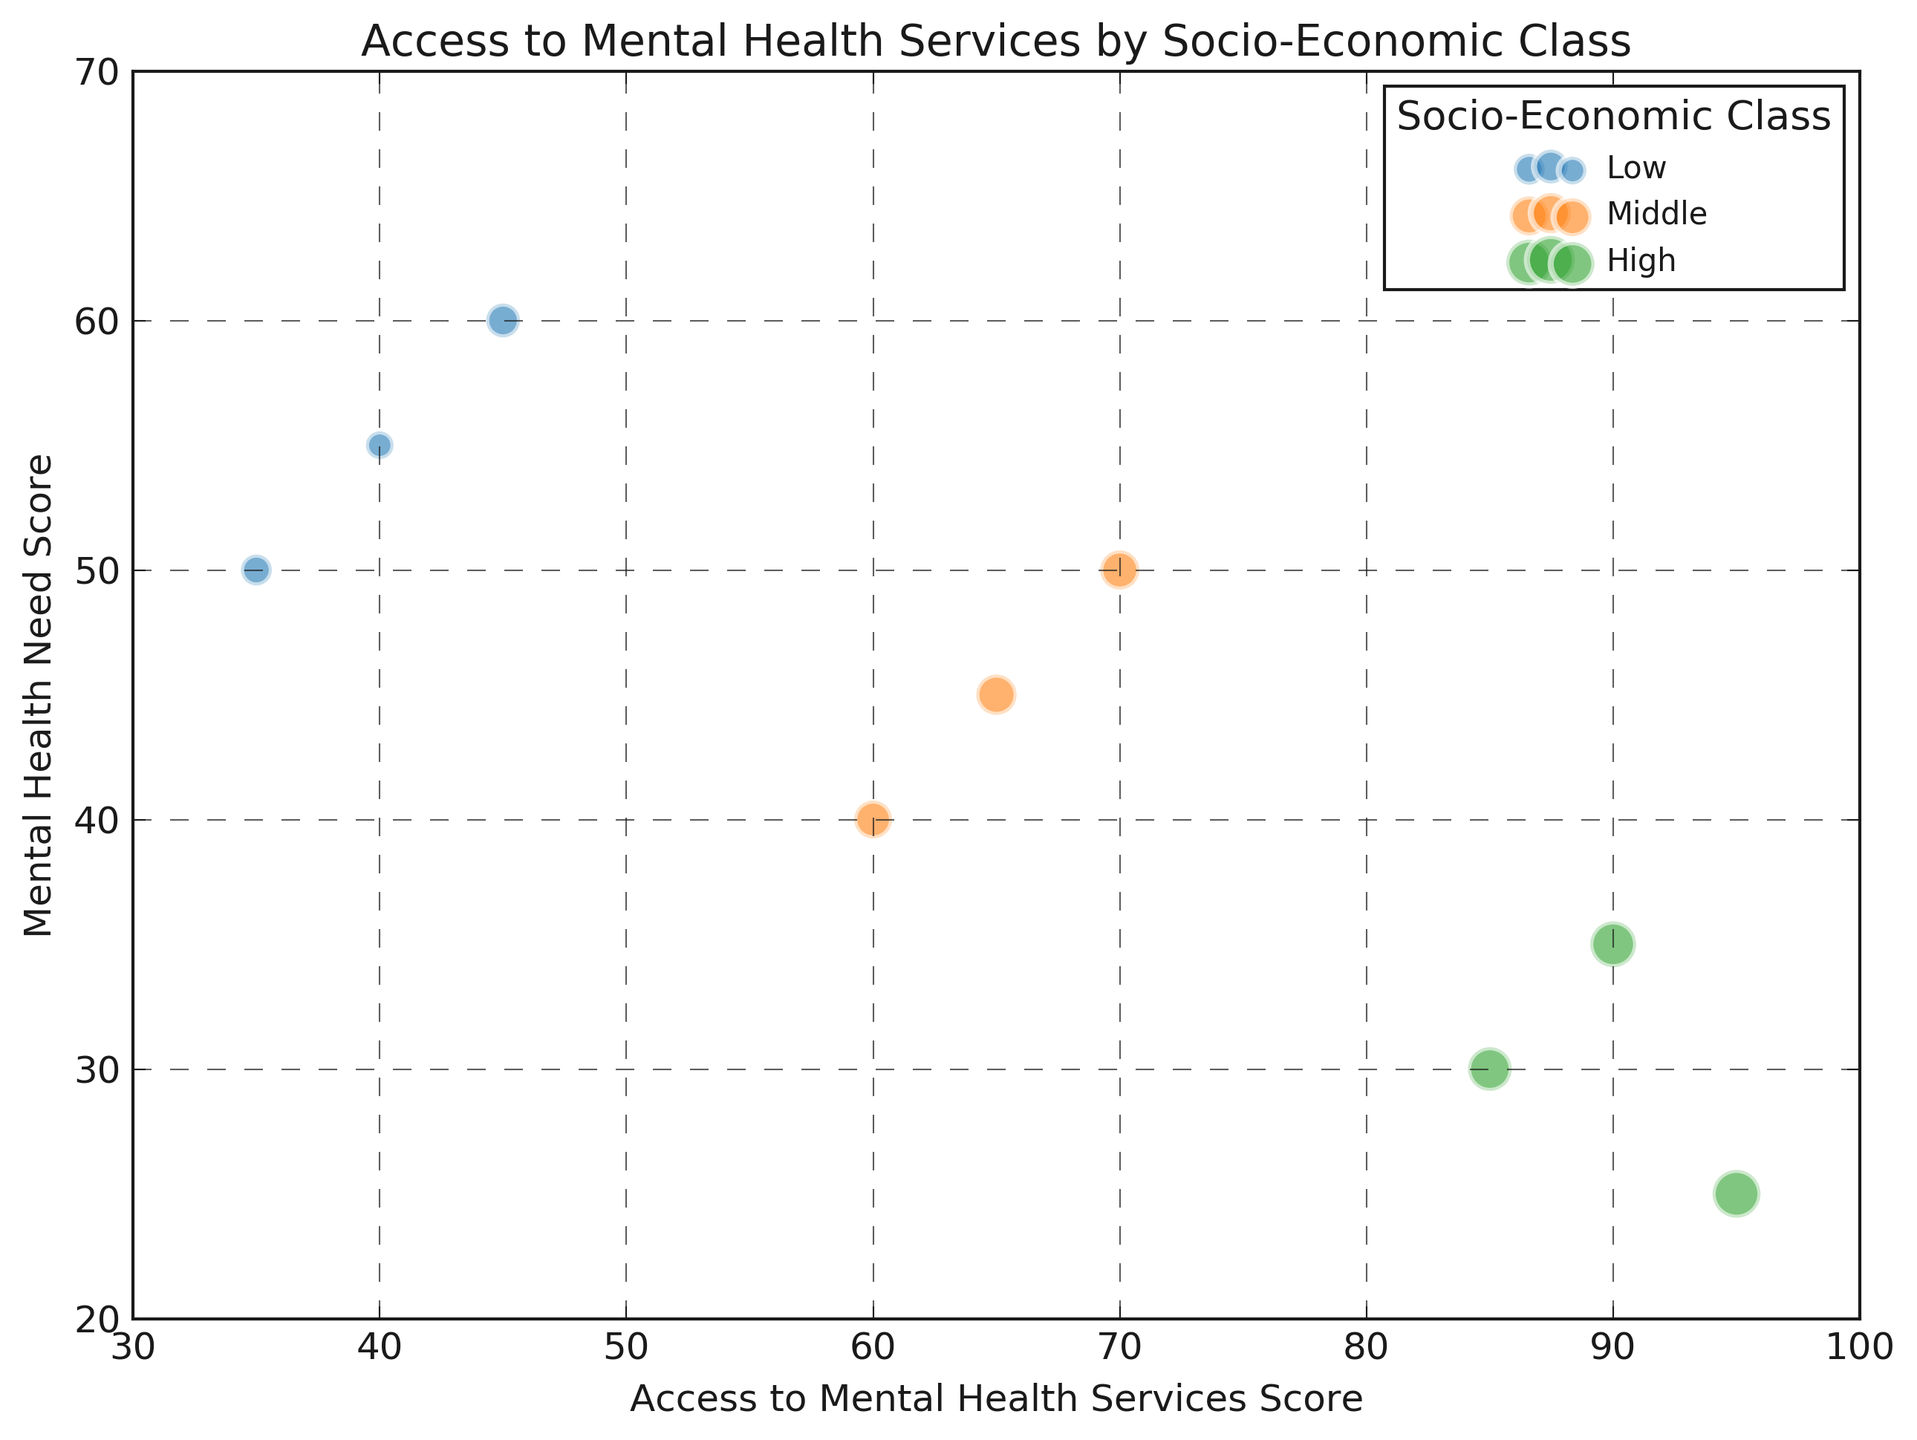What's the class with the lowest average access score? To find the class with the lowest average access score, we calculate the average access score for each socio-economic class. For Low class: (35+40+45)/3 = 40. For Middle class: (60+65+70)/3 = 65. For High class: (85+90+95)/3 = 90. Low class has the lowest average access score.
Answer: Low Which socio-economic class has the largest bubble for the same Mental Health Need Score? For the Mental Health Need Score of 50, we compare the bubble sizes. Low class has a population of 1200, Middle class has a population of 1600, and High class has no data for that score. Middle class has the largest bubble.
Answer: Middle Which socio-economic class generally has higher Access Scores? By observing the placement of the bubbles along the x-axis, High class has Access Scores ranging from 85 to 95, which is generally higher than Middle (60-70) and Low (35-45).
Answer: High Which socio-economic class shows the greatest range in Access Scores? For the range in Access Scores: Low class varies from 35 to 45 (range 10), Middle class varies from 60 to 70 (range 10), and High class varies from 85 to 95 (range 10). All classes show the same range in Access Scores.
Answer: Equal Which class has the greatest mental health need score for the largest bubble? The largest bubble corresponds to the High class with a population of 2400, and the Mental Health Need Score for that bubble is 25.
Answer: High If we consider both Access to Mental Health Services and Mental Health Need, which class seems to need the most improvement? By comparing the combination of low Access Scores and high Mental Health Needs, the Low class (with scores such as 35-45 for access and 50-60 for need) needs the most improvement.
Answer: Low 